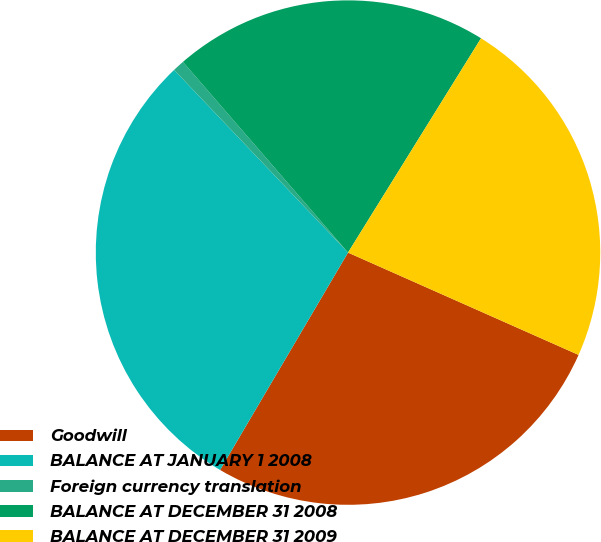Convert chart to OTSL. <chart><loc_0><loc_0><loc_500><loc_500><pie_chart><fcel>Goodwill<fcel>BALANCE AT JANUARY 1 2008<fcel>Foreign currency translation<fcel>BALANCE AT DECEMBER 31 2008<fcel>BALANCE AT DECEMBER 31 2009<nl><fcel>26.82%<fcel>29.43%<fcel>0.75%<fcel>20.2%<fcel>22.81%<nl></chart> 